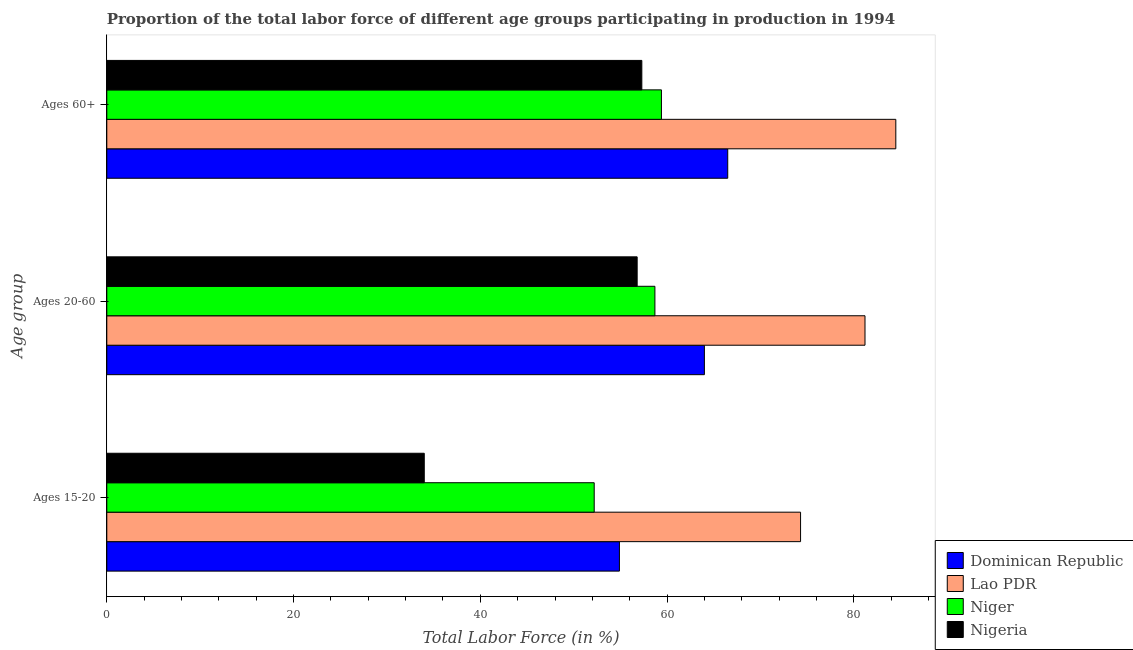How many groups of bars are there?
Offer a terse response. 3. Are the number of bars on each tick of the Y-axis equal?
Offer a terse response. Yes. How many bars are there on the 2nd tick from the top?
Your answer should be very brief. 4. What is the label of the 2nd group of bars from the top?
Your response must be concise. Ages 20-60. What is the percentage of labor force within the age group 20-60 in Lao PDR?
Provide a short and direct response. 81.2. Across all countries, what is the maximum percentage of labor force within the age group 20-60?
Your answer should be compact. 81.2. Across all countries, what is the minimum percentage of labor force within the age group 20-60?
Provide a short and direct response. 56.8. In which country was the percentage of labor force within the age group 20-60 maximum?
Provide a short and direct response. Lao PDR. In which country was the percentage of labor force within the age group 20-60 minimum?
Provide a succinct answer. Nigeria. What is the total percentage of labor force within the age group 15-20 in the graph?
Provide a succinct answer. 215.4. What is the difference between the percentage of labor force within the age group 15-20 in Niger and that in Dominican Republic?
Keep it short and to the point. -2.7. What is the difference between the percentage of labor force within the age group 20-60 in Nigeria and the percentage of labor force within the age group 15-20 in Dominican Republic?
Give a very brief answer. 1.9. What is the average percentage of labor force above age 60 per country?
Ensure brevity in your answer.  66.93. What is the difference between the percentage of labor force within the age group 20-60 and percentage of labor force within the age group 15-20 in Nigeria?
Your response must be concise. 22.8. In how many countries, is the percentage of labor force within the age group 15-20 greater than 52 %?
Offer a terse response. 3. What is the ratio of the percentage of labor force above age 60 in Nigeria to that in Niger?
Your response must be concise. 0.96. Is the difference between the percentage of labor force above age 60 in Lao PDR and Nigeria greater than the difference between the percentage of labor force within the age group 15-20 in Lao PDR and Nigeria?
Make the answer very short. No. What is the difference between the highest and the second highest percentage of labor force within the age group 15-20?
Ensure brevity in your answer.  19.4. What is the difference between the highest and the lowest percentage of labor force above age 60?
Provide a short and direct response. 27.2. What does the 2nd bar from the top in Ages 15-20 represents?
Your answer should be very brief. Niger. What does the 1st bar from the bottom in Ages 15-20 represents?
Ensure brevity in your answer.  Dominican Republic. Are all the bars in the graph horizontal?
Give a very brief answer. Yes. How many countries are there in the graph?
Your answer should be compact. 4. How many legend labels are there?
Offer a very short reply. 4. How are the legend labels stacked?
Offer a terse response. Vertical. What is the title of the graph?
Ensure brevity in your answer.  Proportion of the total labor force of different age groups participating in production in 1994. What is the label or title of the X-axis?
Ensure brevity in your answer.  Total Labor Force (in %). What is the label or title of the Y-axis?
Your response must be concise. Age group. What is the Total Labor Force (in %) in Dominican Republic in Ages 15-20?
Your answer should be very brief. 54.9. What is the Total Labor Force (in %) of Lao PDR in Ages 15-20?
Offer a terse response. 74.3. What is the Total Labor Force (in %) of Niger in Ages 15-20?
Offer a very short reply. 52.2. What is the Total Labor Force (in %) in Nigeria in Ages 15-20?
Your answer should be compact. 34. What is the Total Labor Force (in %) of Dominican Republic in Ages 20-60?
Offer a terse response. 64. What is the Total Labor Force (in %) in Lao PDR in Ages 20-60?
Make the answer very short. 81.2. What is the Total Labor Force (in %) in Niger in Ages 20-60?
Keep it short and to the point. 58.7. What is the Total Labor Force (in %) in Nigeria in Ages 20-60?
Offer a terse response. 56.8. What is the Total Labor Force (in %) of Dominican Republic in Ages 60+?
Offer a very short reply. 66.5. What is the Total Labor Force (in %) in Lao PDR in Ages 60+?
Give a very brief answer. 84.5. What is the Total Labor Force (in %) in Niger in Ages 60+?
Keep it short and to the point. 59.4. What is the Total Labor Force (in %) in Nigeria in Ages 60+?
Your answer should be compact. 57.3. Across all Age group, what is the maximum Total Labor Force (in %) of Dominican Republic?
Your response must be concise. 66.5. Across all Age group, what is the maximum Total Labor Force (in %) of Lao PDR?
Provide a short and direct response. 84.5. Across all Age group, what is the maximum Total Labor Force (in %) of Niger?
Provide a succinct answer. 59.4. Across all Age group, what is the maximum Total Labor Force (in %) in Nigeria?
Your response must be concise. 57.3. Across all Age group, what is the minimum Total Labor Force (in %) in Dominican Republic?
Offer a very short reply. 54.9. Across all Age group, what is the minimum Total Labor Force (in %) of Lao PDR?
Your answer should be compact. 74.3. Across all Age group, what is the minimum Total Labor Force (in %) in Niger?
Offer a very short reply. 52.2. What is the total Total Labor Force (in %) of Dominican Republic in the graph?
Your answer should be very brief. 185.4. What is the total Total Labor Force (in %) in Lao PDR in the graph?
Your response must be concise. 240. What is the total Total Labor Force (in %) of Niger in the graph?
Provide a short and direct response. 170.3. What is the total Total Labor Force (in %) of Nigeria in the graph?
Provide a short and direct response. 148.1. What is the difference between the Total Labor Force (in %) in Niger in Ages 15-20 and that in Ages 20-60?
Ensure brevity in your answer.  -6.5. What is the difference between the Total Labor Force (in %) in Nigeria in Ages 15-20 and that in Ages 20-60?
Make the answer very short. -22.8. What is the difference between the Total Labor Force (in %) in Niger in Ages 15-20 and that in Ages 60+?
Offer a very short reply. -7.2. What is the difference between the Total Labor Force (in %) of Nigeria in Ages 15-20 and that in Ages 60+?
Give a very brief answer. -23.3. What is the difference between the Total Labor Force (in %) of Dominican Republic in Ages 20-60 and that in Ages 60+?
Ensure brevity in your answer.  -2.5. What is the difference between the Total Labor Force (in %) in Lao PDR in Ages 20-60 and that in Ages 60+?
Your response must be concise. -3.3. What is the difference between the Total Labor Force (in %) in Niger in Ages 20-60 and that in Ages 60+?
Offer a very short reply. -0.7. What is the difference between the Total Labor Force (in %) of Dominican Republic in Ages 15-20 and the Total Labor Force (in %) of Lao PDR in Ages 20-60?
Make the answer very short. -26.3. What is the difference between the Total Labor Force (in %) in Lao PDR in Ages 15-20 and the Total Labor Force (in %) in Niger in Ages 20-60?
Offer a terse response. 15.6. What is the difference between the Total Labor Force (in %) in Lao PDR in Ages 15-20 and the Total Labor Force (in %) in Nigeria in Ages 20-60?
Provide a succinct answer. 17.5. What is the difference between the Total Labor Force (in %) of Niger in Ages 15-20 and the Total Labor Force (in %) of Nigeria in Ages 20-60?
Provide a short and direct response. -4.6. What is the difference between the Total Labor Force (in %) in Dominican Republic in Ages 15-20 and the Total Labor Force (in %) in Lao PDR in Ages 60+?
Your answer should be very brief. -29.6. What is the difference between the Total Labor Force (in %) of Lao PDR in Ages 15-20 and the Total Labor Force (in %) of Niger in Ages 60+?
Your response must be concise. 14.9. What is the difference between the Total Labor Force (in %) of Lao PDR in Ages 15-20 and the Total Labor Force (in %) of Nigeria in Ages 60+?
Your response must be concise. 17. What is the difference between the Total Labor Force (in %) of Dominican Republic in Ages 20-60 and the Total Labor Force (in %) of Lao PDR in Ages 60+?
Keep it short and to the point. -20.5. What is the difference between the Total Labor Force (in %) in Dominican Republic in Ages 20-60 and the Total Labor Force (in %) in Niger in Ages 60+?
Ensure brevity in your answer.  4.6. What is the difference between the Total Labor Force (in %) of Dominican Republic in Ages 20-60 and the Total Labor Force (in %) of Nigeria in Ages 60+?
Ensure brevity in your answer.  6.7. What is the difference between the Total Labor Force (in %) in Lao PDR in Ages 20-60 and the Total Labor Force (in %) in Niger in Ages 60+?
Provide a short and direct response. 21.8. What is the difference between the Total Labor Force (in %) in Lao PDR in Ages 20-60 and the Total Labor Force (in %) in Nigeria in Ages 60+?
Provide a succinct answer. 23.9. What is the difference between the Total Labor Force (in %) in Niger in Ages 20-60 and the Total Labor Force (in %) in Nigeria in Ages 60+?
Give a very brief answer. 1.4. What is the average Total Labor Force (in %) of Dominican Republic per Age group?
Ensure brevity in your answer.  61.8. What is the average Total Labor Force (in %) in Lao PDR per Age group?
Offer a very short reply. 80. What is the average Total Labor Force (in %) of Niger per Age group?
Your response must be concise. 56.77. What is the average Total Labor Force (in %) in Nigeria per Age group?
Provide a short and direct response. 49.37. What is the difference between the Total Labor Force (in %) in Dominican Republic and Total Labor Force (in %) in Lao PDR in Ages 15-20?
Provide a short and direct response. -19.4. What is the difference between the Total Labor Force (in %) in Dominican Republic and Total Labor Force (in %) in Nigeria in Ages 15-20?
Offer a very short reply. 20.9. What is the difference between the Total Labor Force (in %) of Lao PDR and Total Labor Force (in %) of Niger in Ages 15-20?
Make the answer very short. 22.1. What is the difference between the Total Labor Force (in %) of Lao PDR and Total Labor Force (in %) of Nigeria in Ages 15-20?
Keep it short and to the point. 40.3. What is the difference between the Total Labor Force (in %) of Niger and Total Labor Force (in %) of Nigeria in Ages 15-20?
Make the answer very short. 18.2. What is the difference between the Total Labor Force (in %) of Dominican Republic and Total Labor Force (in %) of Lao PDR in Ages 20-60?
Offer a terse response. -17.2. What is the difference between the Total Labor Force (in %) of Dominican Republic and Total Labor Force (in %) of Niger in Ages 20-60?
Keep it short and to the point. 5.3. What is the difference between the Total Labor Force (in %) in Lao PDR and Total Labor Force (in %) in Niger in Ages 20-60?
Ensure brevity in your answer.  22.5. What is the difference between the Total Labor Force (in %) of Lao PDR and Total Labor Force (in %) of Nigeria in Ages 20-60?
Provide a succinct answer. 24.4. What is the difference between the Total Labor Force (in %) in Niger and Total Labor Force (in %) in Nigeria in Ages 20-60?
Your answer should be compact. 1.9. What is the difference between the Total Labor Force (in %) in Dominican Republic and Total Labor Force (in %) in Lao PDR in Ages 60+?
Your response must be concise. -18. What is the difference between the Total Labor Force (in %) of Dominican Republic and Total Labor Force (in %) of Niger in Ages 60+?
Offer a very short reply. 7.1. What is the difference between the Total Labor Force (in %) of Dominican Republic and Total Labor Force (in %) of Nigeria in Ages 60+?
Your response must be concise. 9.2. What is the difference between the Total Labor Force (in %) of Lao PDR and Total Labor Force (in %) of Niger in Ages 60+?
Offer a very short reply. 25.1. What is the difference between the Total Labor Force (in %) in Lao PDR and Total Labor Force (in %) in Nigeria in Ages 60+?
Your answer should be compact. 27.2. What is the difference between the Total Labor Force (in %) of Niger and Total Labor Force (in %) of Nigeria in Ages 60+?
Offer a very short reply. 2.1. What is the ratio of the Total Labor Force (in %) of Dominican Republic in Ages 15-20 to that in Ages 20-60?
Give a very brief answer. 0.86. What is the ratio of the Total Labor Force (in %) of Lao PDR in Ages 15-20 to that in Ages 20-60?
Ensure brevity in your answer.  0.92. What is the ratio of the Total Labor Force (in %) of Niger in Ages 15-20 to that in Ages 20-60?
Your answer should be compact. 0.89. What is the ratio of the Total Labor Force (in %) in Nigeria in Ages 15-20 to that in Ages 20-60?
Your answer should be very brief. 0.6. What is the ratio of the Total Labor Force (in %) in Dominican Republic in Ages 15-20 to that in Ages 60+?
Give a very brief answer. 0.83. What is the ratio of the Total Labor Force (in %) of Lao PDR in Ages 15-20 to that in Ages 60+?
Offer a terse response. 0.88. What is the ratio of the Total Labor Force (in %) of Niger in Ages 15-20 to that in Ages 60+?
Give a very brief answer. 0.88. What is the ratio of the Total Labor Force (in %) of Nigeria in Ages 15-20 to that in Ages 60+?
Your answer should be compact. 0.59. What is the ratio of the Total Labor Force (in %) in Dominican Republic in Ages 20-60 to that in Ages 60+?
Provide a short and direct response. 0.96. What is the ratio of the Total Labor Force (in %) in Lao PDR in Ages 20-60 to that in Ages 60+?
Offer a very short reply. 0.96. What is the ratio of the Total Labor Force (in %) in Niger in Ages 20-60 to that in Ages 60+?
Your answer should be compact. 0.99. What is the ratio of the Total Labor Force (in %) of Nigeria in Ages 20-60 to that in Ages 60+?
Give a very brief answer. 0.99. What is the difference between the highest and the second highest Total Labor Force (in %) of Dominican Republic?
Offer a terse response. 2.5. What is the difference between the highest and the second highest Total Labor Force (in %) of Niger?
Ensure brevity in your answer.  0.7. What is the difference between the highest and the second highest Total Labor Force (in %) in Nigeria?
Your answer should be compact. 0.5. What is the difference between the highest and the lowest Total Labor Force (in %) in Dominican Republic?
Provide a short and direct response. 11.6. What is the difference between the highest and the lowest Total Labor Force (in %) of Lao PDR?
Provide a short and direct response. 10.2. What is the difference between the highest and the lowest Total Labor Force (in %) in Niger?
Offer a very short reply. 7.2. What is the difference between the highest and the lowest Total Labor Force (in %) in Nigeria?
Provide a succinct answer. 23.3. 